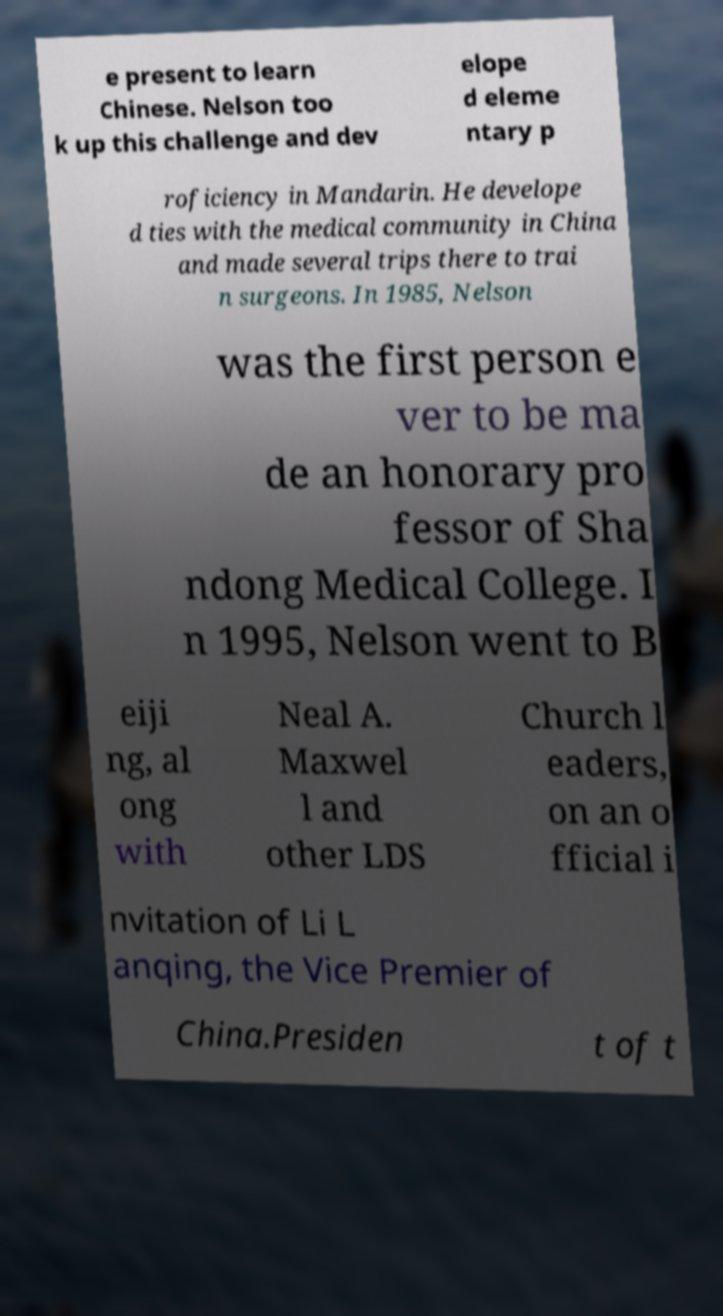There's text embedded in this image that I need extracted. Can you transcribe it verbatim? e present to learn Chinese. Nelson too k up this challenge and dev elope d eleme ntary p roficiency in Mandarin. He develope d ties with the medical community in China and made several trips there to trai n surgeons. In 1985, Nelson was the first person e ver to be ma de an honorary pro fessor of Sha ndong Medical College. I n 1995, Nelson went to B eiji ng, al ong with Neal A. Maxwel l and other LDS Church l eaders, on an o fficial i nvitation of Li L anqing, the Vice Premier of China.Presiden t of t 